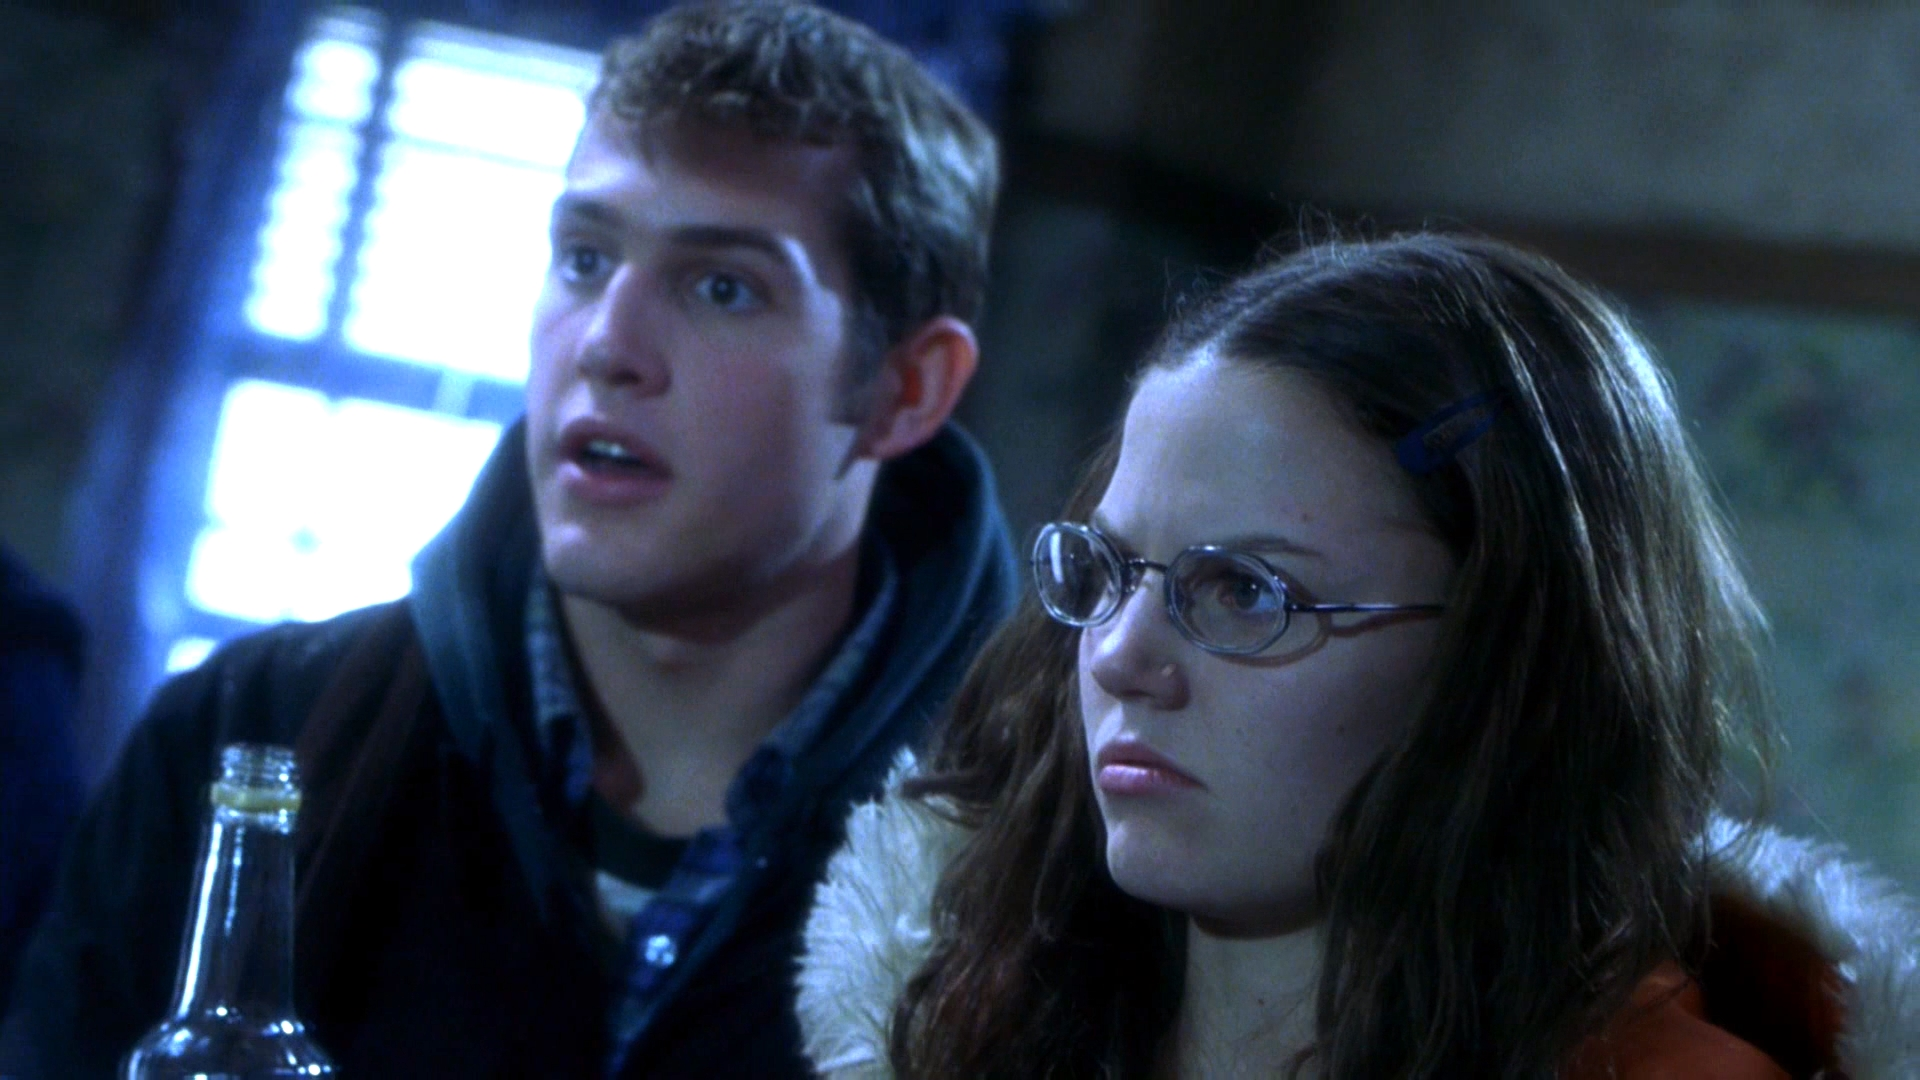Can you elaborate on the elements of the picture provided? In this image, we see two individuals presenting a vivid scene, possibly from their work environment or a moment in a story. The woman, wearing a striking red jacket and clear glasses, stands on the right. She holds a clear bottle in her hands. On the left, a man in a blue jacket, begins to glance sidewards, sharing the woman's concerned expression. Their similar shocked expressions suggest they are reacting to an unexpected event off-camera. This scene might be crafted to depict tension or surprise in a dramatic or narrative setting, possibly indicating a pivotal plot development. 